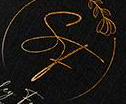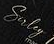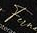What words are shown in these images in order, separated by a semicolon? SF; Suley; Fu 